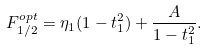<formula> <loc_0><loc_0><loc_500><loc_500>F ^ { o p t } _ { 1 / 2 } = \eta _ { 1 } ( 1 - t _ { 1 } ^ { 2 } ) + \frac { A } { 1 - t _ { 1 } ^ { 2 } } .</formula> 